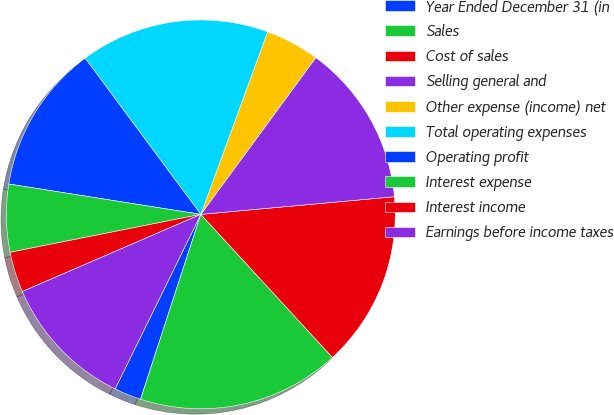Convert chart. <chart><loc_0><loc_0><loc_500><loc_500><pie_chart><fcel>Year Ended December 31 (in<fcel>Sales<fcel>Cost of sales<fcel>Selling general and<fcel>Other expense (income) net<fcel>Total operating expenses<fcel>Operating profit<fcel>Interest expense<fcel>Interest income<fcel>Earnings before income taxes<nl><fcel>2.25%<fcel>16.85%<fcel>14.61%<fcel>13.48%<fcel>4.49%<fcel>15.73%<fcel>12.36%<fcel>5.62%<fcel>3.37%<fcel>11.24%<nl></chart> 